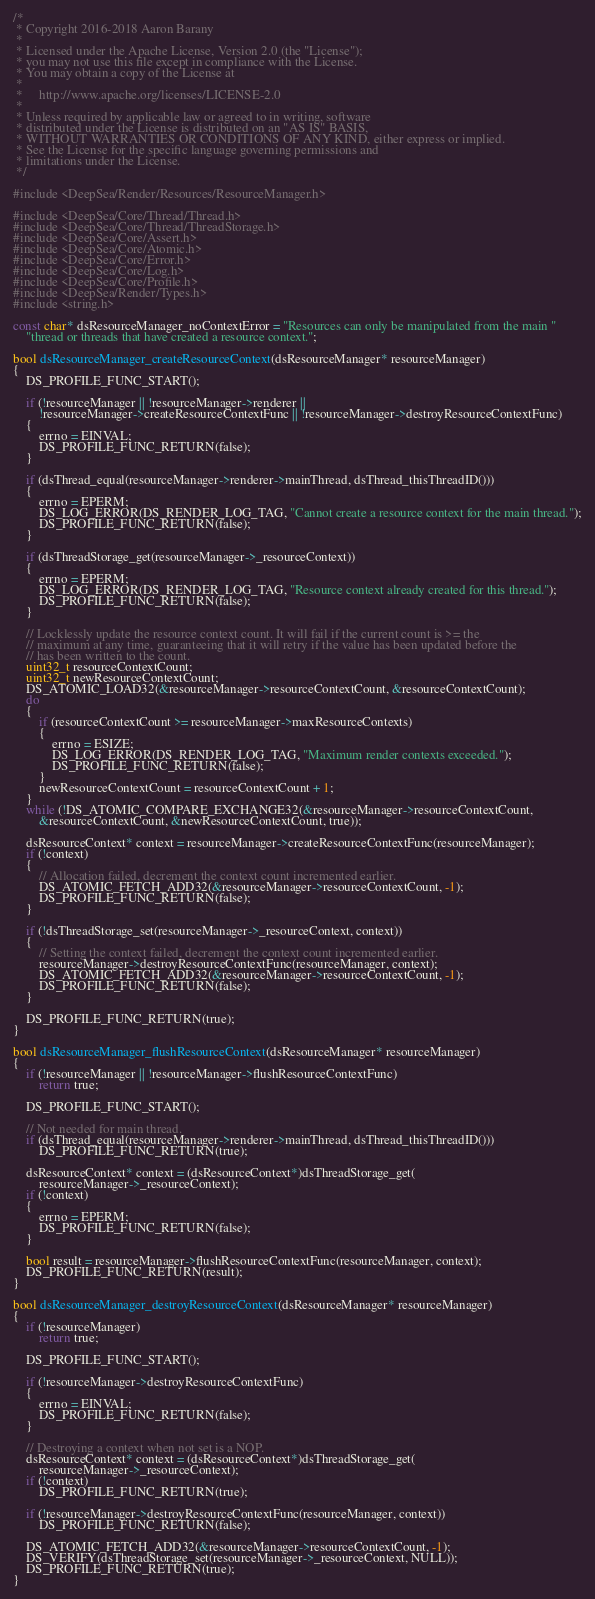<code> <loc_0><loc_0><loc_500><loc_500><_C_>/*
 * Copyright 2016-2018 Aaron Barany
 *
 * Licensed under the Apache License, Version 2.0 (the "License");
 * you may not use this file except in compliance with the License.
 * You may obtain a copy of the License at
 *
 *     http://www.apache.org/licenses/LICENSE-2.0
 *
 * Unless required by applicable law or agreed to in writing, software
 * distributed under the License is distributed on an "AS IS" BASIS,
 * WITHOUT WARRANTIES OR CONDITIONS OF ANY KIND, either express or implied.
 * See the License for the specific language governing permissions and
 * limitations under the License.
 */

#include <DeepSea/Render/Resources/ResourceManager.h>

#include <DeepSea/Core/Thread/Thread.h>
#include <DeepSea/Core/Thread/ThreadStorage.h>
#include <DeepSea/Core/Assert.h>
#include <DeepSea/Core/Atomic.h>
#include <DeepSea/Core/Error.h>
#include <DeepSea/Core/Log.h>
#include <DeepSea/Core/Profile.h>
#include <DeepSea/Render/Types.h>
#include <string.h>

const char* dsResourceManager_noContextError = "Resources can only be manipulated from the main "
	"thread or threads that have created a resource context.";

bool dsResourceManager_createResourceContext(dsResourceManager* resourceManager)
{
	DS_PROFILE_FUNC_START();

	if (!resourceManager || !resourceManager->renderer ||
		!resourceManager->createResourceContextFunc || !resourceManager->destroyResourceContextFunc)
	{
		errno = EINVAL;
		DS_PROFILE_FUNC_RETURN(false);
	}

	if (dsThread_equal(resourceManager->renderer->mainThread, dsThread_thisThreadID()))
	{
		errno = EPERM;
		DS_LOG_ERROR(DS_RENDER_LOG_TAG, "Cannot create a resource context for the main thread.");
		DS_PROFILE_FUNC_RETURN(false);
	}

	if (dsThreadStorage_get(resourceManager->_resourceContext))
	{
		errno = EPERM;
		DS_LOG_ERROR(DS_RENDER_LOG_TAG, "Resource context already created for this thread.");
		DS_PROFILE_FUNC_RETURN(false);
	}

	// Locklessly update the resource context count. It will fail if the current count is >= the
	// maximum at any time, guaranteeing that it will retry if the value has been updated before the
	// has been written to the count.
	uint32_t resourceContextCount;
	uint32_t newResourceContextCount;
	DS_ATOMIC_LOAD32(&resourceManager->resourceContextCount, &resourceContextCount);
	do
	{
		if (resourceContextCount >= resourceManager->maxResourceContexts)
		{
			errno = ESIZE;
			DS_LOG_ERROR(DS_RENDER_LOG_TAG, "Maximum render contexts exceeded.");
			DS_PROFILE_FUNC_RETURN(false);
		}
		newResourceContextCount = resourceContextCount + 1;
	}
	while (!DS_ATOMIC_COMPARE_EXCHANGE32(&resourceManager->resourceContextCount,
		&resourceContextCount, &newResourceContextCount, true));

	dsResourceContext* context = resourceManager->createResourceContextFunc(resourceManager);
	if (!context)
	{
		// Allocation failed, decrement the context count incremented earlier.
		DS_ATOMIC_FETCH_ADD32(&resourceManager->resourceContextCount, -1);
		DS_PROFILE_FUNC_RETURN(false);
	}

	if (!dsThreadStorage_set(resourceManager->_resourceContext, context))
	{
		// Setting the context failed, decrement the context count incremented earlier.
		resourceManager->destroyResourceContextFunc(resourceManager, context);
		DS_ATOMIC_FETCH_ADD32(&resourceManager->resourceContextCount, -1);
		DS_PROFILE_FUNC_RETURN(false);
	}

	DS_PROFILE_FUNC_RETURN(true);
}

bool dsResourceManager_flushResourceContext(dsResourceManager* resourceManager)
{
	if (!resourceManager || !resourceManager->flushResourceContextFunc)
		return true;

	DS_PROFILE_FUNC_START();

	// Not needed for main thread.
	if (dsThread_equal(resourceManager->renderer->mainThread, dsThread_thisThreadID()))
		DS_PROFILE_FUNC_RETURN(true);

	dsResourceContext* context = (dsResourceContext*)dsThreadStorage_get(
		resourceManager->_resourceContext);
	if (!context)
	{
		errno = EPERM;
		DS_PROFILE_FUNC_RETURN(false);
	}

	bool result = resourceManager->flushResourceContextFunc(resourceManager, context);
	DS_PROFILE_FUNC_RETURN(result);
}

bool dsResourceManager_destroyResourceContext(dsResourceManager* resourceManager)
{
	if (!resourceManager)
		return true;

	DS_PROFILE_FUNC_START();

	if (!resourceManager->destroyResourceContextFunc)
	{
		errno = EINVAL;
		DS_PROFILE_FUNC_RETURN(false);
	}

	// Destroying a context when not set is a NOP.
	dsResourceContext* context = (dsResourceContext*)dsThreadStorage_get(
		resourceManager->_resourceContext);
	if (!context)
		DS_PROFILE_FUNC_RETURN(true);

	if (!resourceManager->destroyResourceContextFunc(resourceManager, context))
		DS_PROFILE_FUNC_RETURN(false);

	DS_ATOMIC_FETCH_ADD32(&resourceManager->resourceContextCount, -1);
	DS_VERIFY(dsThreadStorage_set(resourceManager->_resourceContext, NULL));
	DS_PROFILE_FUNC_RETURN(true);
}
</code> 